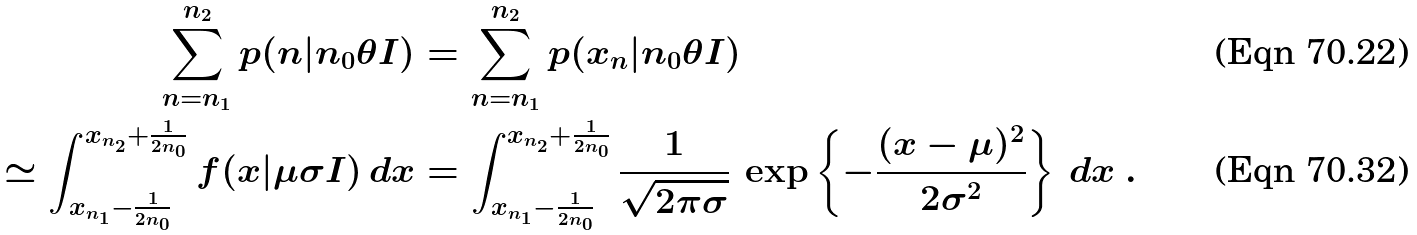Convert formula to latex. <formula><loc_0><loc_0><loc_500><loc_500>\sum _ { n = n _ { 1 } } ^ { n _ { 2 } } p ( n | n _ { 0 } \theta I ) & = \sum _ { n = n _ { 1 } } ^ { n _ { 2 } } p ( x _ { n } | n _ { 0 } \theta I ) \\ \simeq \int _ { x _ { n _ { 1 } } - \frac { 1 } { 2 n _ { 0 } } } ^ { x _ { n _ { 2 } } + \frac { 1 } { 2 n _ { 0 } } } f ( x | \mu \sigma I ) \, d x & = \int _ { x _ { n _ { 1 } } - \frac { 1 } { 2 n _ { 0 } } } ^ { x _ { n _ { 2 } } + \frac { 1 } { 2 n _ { 0 } } } \frac { 1 } { \sqrt { 2 \pi \sigma } } \, \exp \left \{ - \frac { ( x - \mu ) ^ { 2 } } { 2 \sigma ^ { 2 } } \right \} \, d x \ .</formula> 